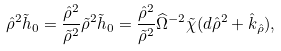Convert formula to latex. <formula><loc_0><loc_0><loc_500><loc_500>\hat { \rho } ^ { 2 } \tilde { h } _ { 0 } = \frac { \hat { \rho } ^ { 2 } } { \tilde { \rho } ^ { 2 } } \tilde { \rho } ^ { 2 } \tilde { h } _ { 0 } = \frac { \hat { \rho } ^ { 2 } } { \tilde { \rho } ^ { 2 } } \widehat { \Omega } ^ { - 2 } \tilde { \chi } ( d \hat { \rho } ^ { 2 } + \hat { k } _ { \hat { \rho } } ) ,</formula> 